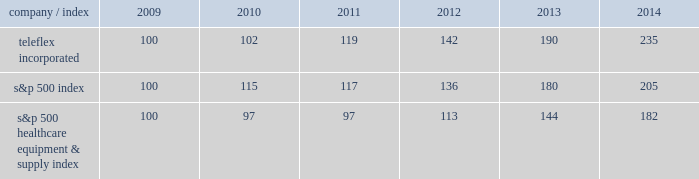Stock performance graph the following graph provides a comparison of five year cumulative total stockholder returns of teleflex common stock , the standard & poor 2019s ( s&p ) 500 stock index and the s&p 500 healthcare equipment & supply index .
The annual changes for the five-year period shown on the graph are based on the assumption that $ 100 had been invested in teleflex common stock and each index on december 31 , 2009 and that all dividends were reinvested .
Market performance .
S&p 500 healthcare equipment & supply index 100 97 97 113 144 182 .
What is the total percentage growth for the s&p 500 index from 2010-2014? 
Computations: (205 / 100)
Answer: 2.05. 